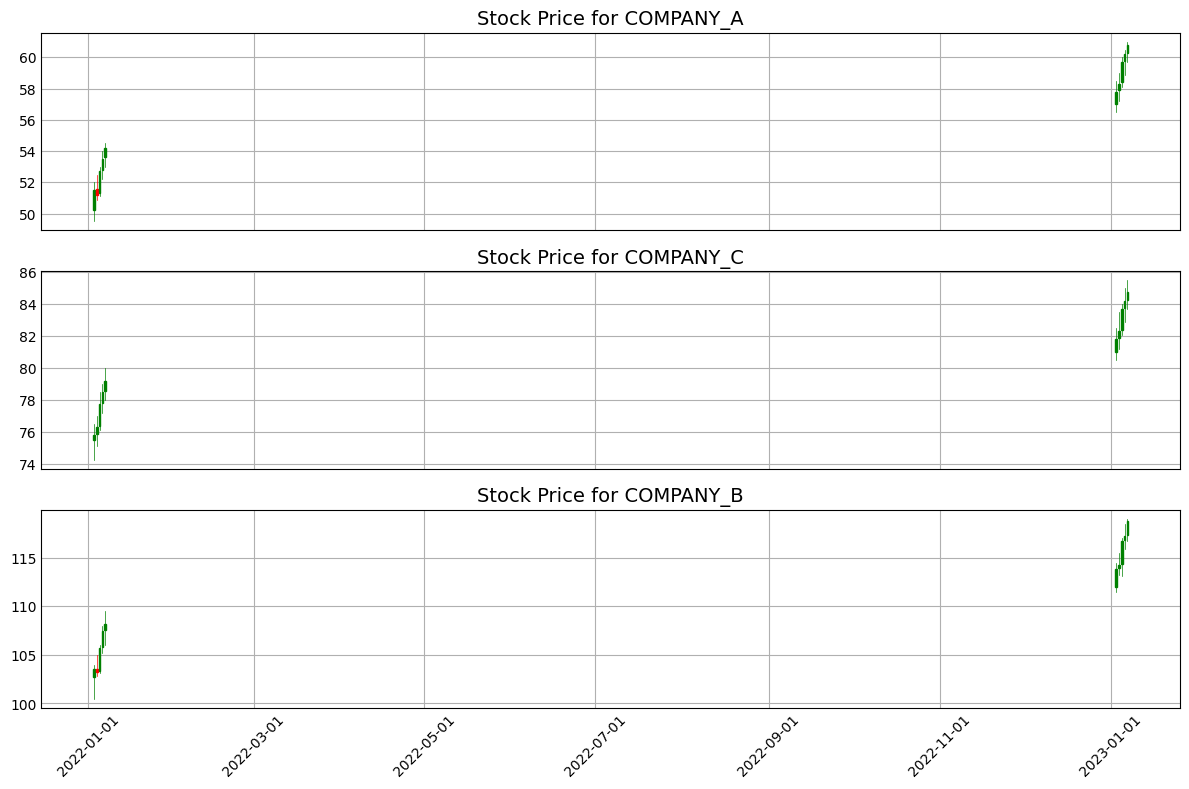What is the closing price difference for COMPANY_A between January 7, 2022, and January 7, 2023? The closing price on January 7, 2022, for COMPANY_A is 54.20. The closing price on January 7, 2023, is 60.80. The difference is 60.80 - 54.20 = 6.60
Answer: 6.60 How does the highest price of COMPANY_B on January 6, 2022, compare to the highest price on January 6, 2023? The highest price on January 6, 2022, for COMPANY_B is 108.00. The highest price on January 6, 2023, is 118.50. 118.50 is greater than 108.00
Answer: Greater Which company saw the highest increase in closing price from January 3, 2022, to January 3, 2023? COMPANY_A: 51.50 to 57.80 (6.30 increase); COMPANY_B: 103.50 to 113.80 (10.30 increase); COMPANY_C: 75.80 to 81.80 (6.00 increase). The highest increase is 10.30 for COMPANY_B
Answer: COMPANY_B Between all three companies, which one had the highest closing price on January 5, 2023? COMPANY_A: 59.70; COMPANY_B: 116.70; COMPANY_C: 83.70. The highest closing price is 116.70 for COMPANY_B
Answer: COMPANY_B What is the average closing price for COMPANY_C in the data provided for January 2022? Closing prices for January 2022: 75.80, 76.30, 77.75, 78.50, 79.20. Sum = 75.80 + 76.30 + 77.75 + 78.50 + 79.20 = 387.55. Average = 387.55 / 5 = 77.51
Answer: 77.51 Did COMPANY_A's stock price have an increasing trend over the first week of January 2023? From January 3, 2023, to January 7, 2023, the closing prices for COMPANY_A are: 57.80, 58.30, 59.70, 60.20, 60.80. They are in an increasing order
Answer: Yes For the week of January 5, 2023, to January 7, 2023, which company had the smallest range between its high and low prices? COMPANY_A: 60.00 - 58.10 = 1.90 (Jan 5), 60.50 - 58.90 = 1.60 (Jan 6), 61.00 - 59.70 = 1.30 (Jan 7); COMPANY_B: 117.00 - 113.10 = 3.90 (Jan 5), 118.50 - 115.90 = 2.60 (Jan 6), 119.00 - 116.70 = 2.30 (Jan 7); COMPANY_C: 84.00 - 82.10 = 1.90 (Jan 5), 85.00 - 82.90 = 2.10 (Jan 6), 85.50 - 83.70 = 1.80 (Jan 7). The smallest range is for COMPANY_A on January 7 with 1.30
Answer: COMPANY_A What is the total volume traded for COMPANY_C over the first week of January 2023? Volume for January 3, 4, 5, 6, and 7 are 1500000, 1450000, 1520000, 1400000, 1550000 respectively. Total = 1500000 + 1450000 + 1520000 + 1400000 + 1550000 = 7420000
Answer: 7420000 